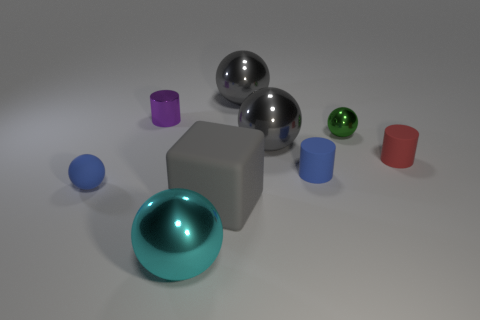What could be the possible function of these objects, considering their shapes and arrangement? The objects don't seem to have a specific function as they are more likely used for display purposes due to their geometric shapes and the way they are uniformly spaced. They could serve as models for a 3D rendering test or an illustration of geometric shapes and reflections. 